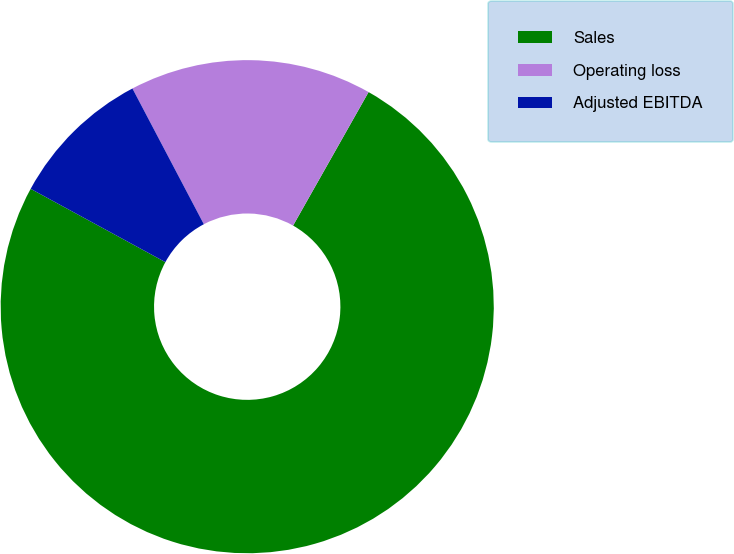Convert chart to OTSL. <chart><loc_0><loc_0><loc_500><loc_500><pie_chart><fcel>Sales<fcel>Operating loss<fcel>Adjusted EBITDA<nl><fcel>74.75%<fcel>15.9%<fcel>9.36%<nl></chart> 